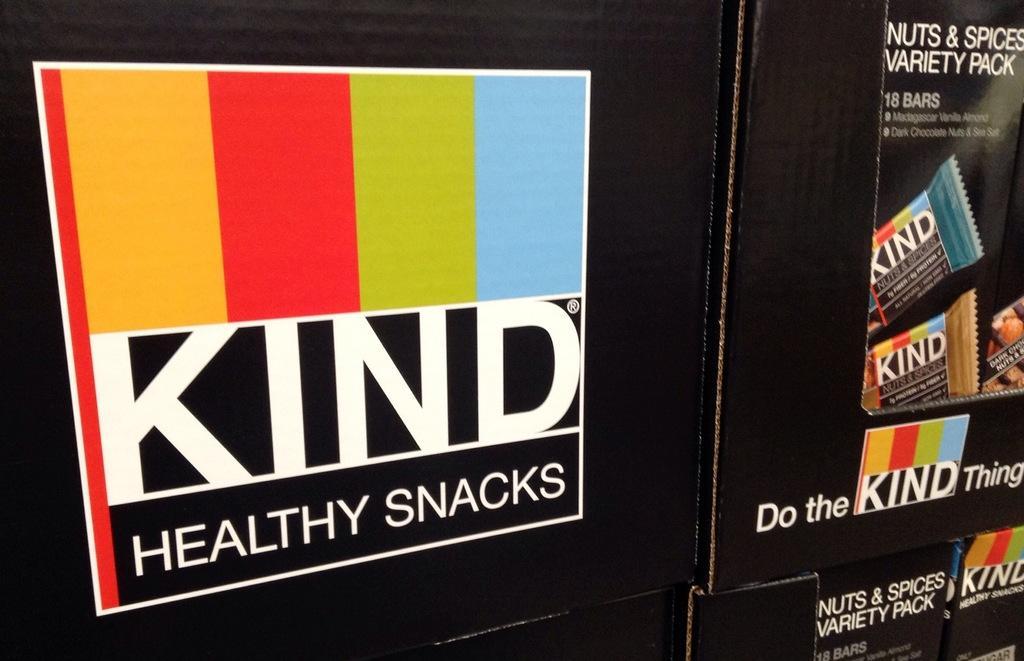Describe this image in one or two sentences. In this image, we can see snacks boxes. 